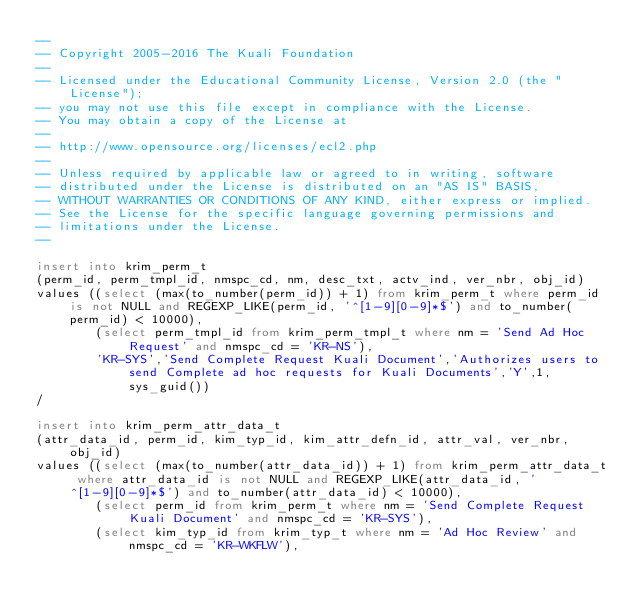<code> <loc_0><loc_0><loc_500><loc_500><_SQL_>--
-- Copyright 2005-2016 The Kuali Foundation
--
-- Licensed under the Educational Community License, Version 2.0 (the "License");
-- you may not use this file except in compliance with the License.
-- You may obtain a copy of the License at
--
-- http://www.opensource.org/licenses/ecl2.php
--
-- Unless required by applicable law or agreed to in writing, software
-- distributed under the License is distributed on an "AS IS" BASIS,
-- WITHOUT WARRANTIES OR CONDITIONS OF ANY KIND, either express or implied.
-- See the License for the specific language governing permissions and
-- limitations under the License.
--

insert into krim_perm_t
(perm_id, perm_tmpl_id, nmspc_cd, nm, desc_txt, actv_ind, ver_nbr, obj_id)
values ((select (max(to_number(perm_id)) + 1) from krim_perm_t where perm_id is not NULL and REGEXP_LIKE(perm_id, '^[1-9][0-9]*$') and to_number(perm_id) < 10000),
        (select perm_tmpl_id from krim_perm_tmpl_t where nm = 'Send Ad Hoc Request' and nmspc_cd = 'KR-NS'),
        'KR-SYS','Send Complete Request Kuali Document','Authorizes users to send Complete ad hoc requests for Kuali Documents','Y',1,sys_guid())
/

insert into krim_perm_attr_data_t
(attr_data_id, perm_id, kim_typ_id, kim_attr_defn_id, attr_val, ver_nbr, obj_id)
values ((select (max(to_number(attr_data_id)) + 1) from krim_perm_attr_data_t where attr_data_id is not NULL and REGEXP_LIKE(attr_data_id, '^[1-9][0-9]*$') and to_number(attr_data_id) < 10000),
        (select perm_id from krim_perm_t where nm = 'Send Complete Request Kuali Document' and nmspc_cd = 'KR-SYS'),
        (select kim_typ_id from krim_typ_t where nm = 'Ad Hoc Review' and nmspc_cd = 'KR-WKFLW'),</code> 